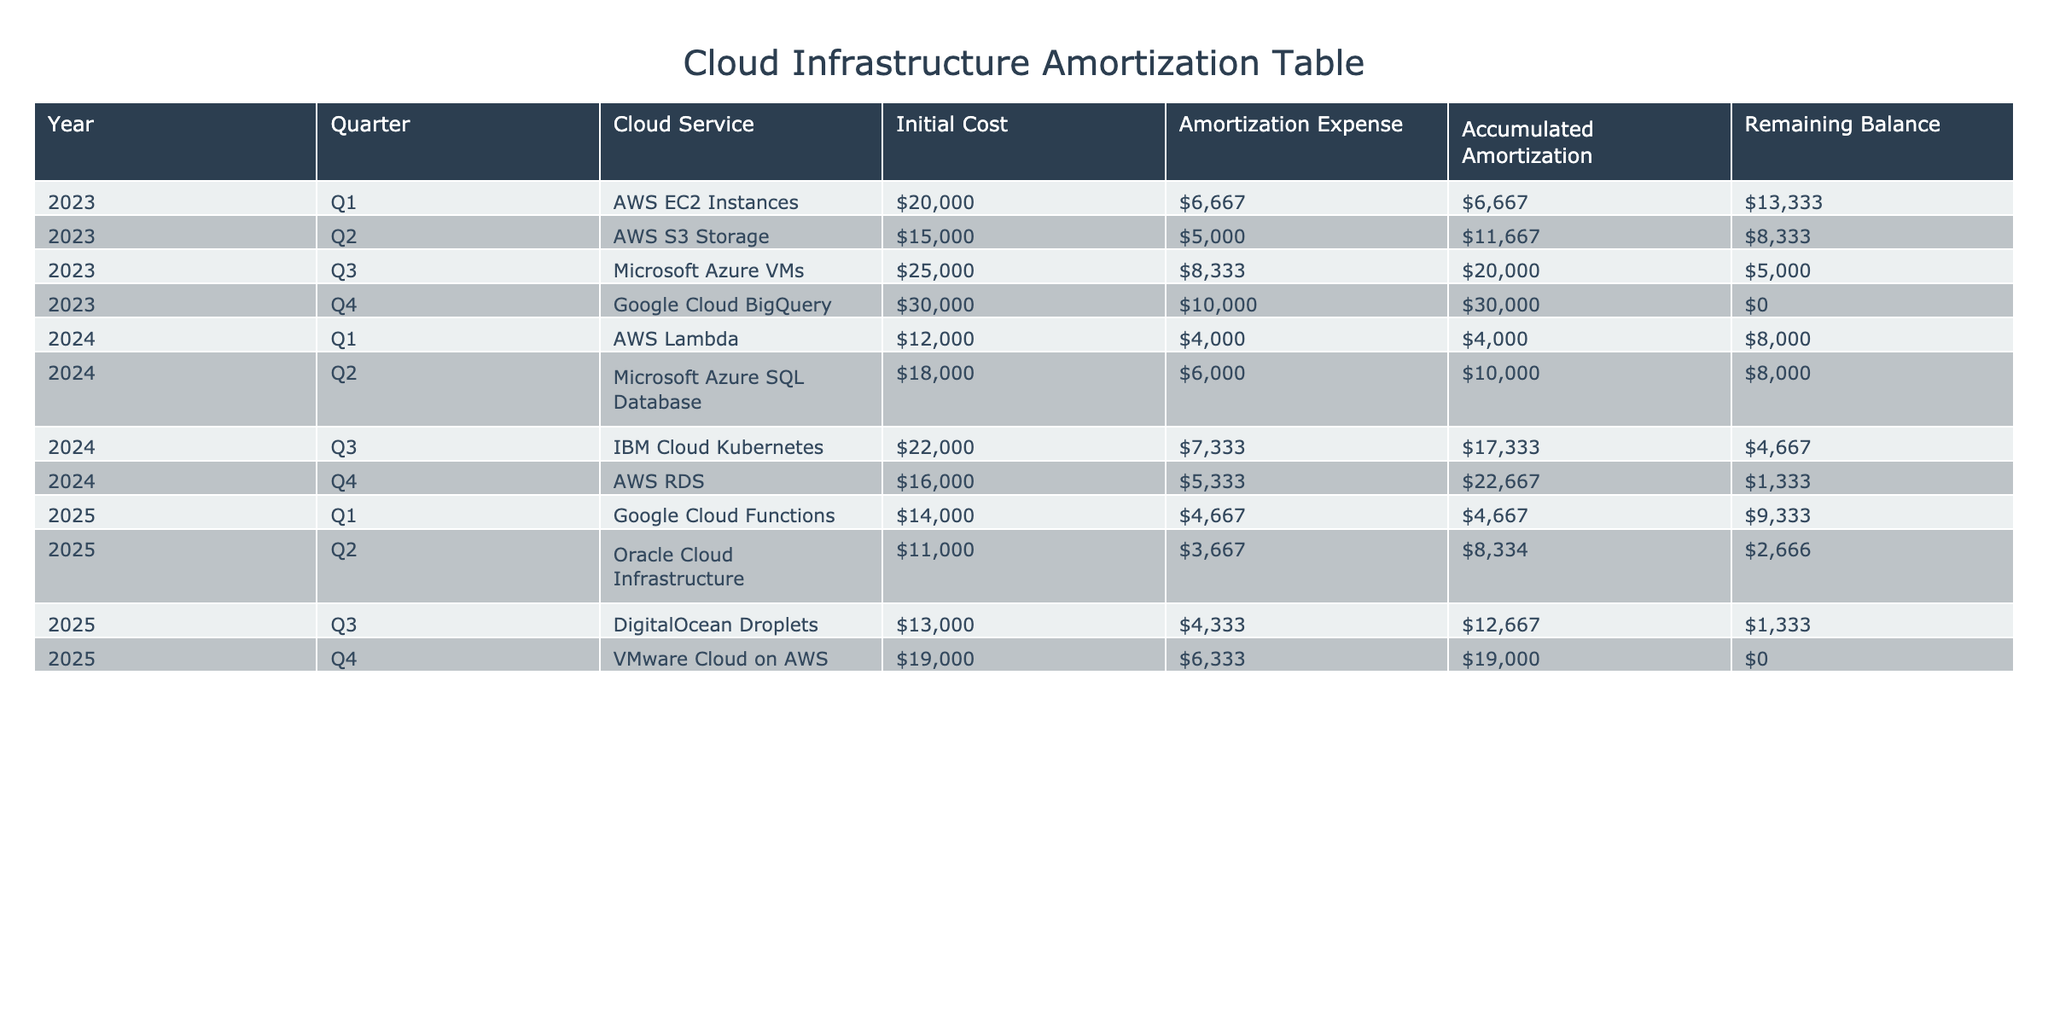What is the total Initial Cost for cloud services in 2023? The Initial Costs for cloud services in 2023 are: AWS EC2 Instances ($20,000), AWS S3 Storage ($15,000), Microsoft Azure VMs ($25,000), and Google Cloud BigQuery ($30,000). Adding these amounts: 20,000 + 15,000 + 25,000 + 30,000 = 90,000.
Answer: $90,000 How much was the Amortization Expense for Google Cloud BigQuery? From the table, the Amortization Expense for Google Cloud BigQuery in Q4 2023 is $10,000.
Answer: $10,000 Is the Remaining Balance for AWS RDS in Q4 2024 equal to $1,333? According to the table, the Remaining Balance for AWS RDS in Q4 2024 is $1,333, so the statement is true.
Answer: Yes What is the average Amortization Expense for the year 2024? The Amortization Expenses for 2024 are: $4,000 (Q1), $6,000 (Q2), $7,333 (Q3), and $5,333 (Q4). First, sum these amounts: 4,000 + 6,000 + 7,333 + 5,333 = 22,666. Then, divide by 4 (the number of entries): 22,666 / 4 = 5,666.5.
Answer: $5,666.50 Which cloud service had the highest Remaining Balance in Q2 2024? In Q2 2024, the Remaining Balances are: AWS Lambda ($8,000), Microsoft Azure SQL Database ($8,000), IBM Cloud Kubernetes ($4,667), and AWS RDS ($1,333). Highest value is $8,000 for both AWS Lambda and Microsoft Azure SQL Database.
Answer: AWS Lambda and Microsoft Azure SQL Database What is the total Accumulated Amortization at the end of 2025? At the end of 2025, the Accumulated Amortization values are: Q1 ($4,667), Q2 ($8,334), Q3 ($12,667), and Q4 ($19,000). Summing these gives: 4,667 + 8,334 + 12,667 + 19,000 = 44,668.
Answer: $44,668 Did AWS EC2 Instances have an Amortization Expense greater than $7,000? The Amortization Expense for AWS EC2 Instances in Q1 2023 is $6,667, which is less than $7,000, making this statement false.
Answer: No What is the Remaining Balance for DigitalOcean Droplets in Q3 2025? The Remaining Balance for DigitalOcean Droplets in Q3 2025 is $1,333 according to the table.
Answer: $1,333 What is the total Initial Cost across all cloud services listed? The Initial Costs in the table are: $20,000, $15,000, $25,000, $30,000, $12,000, $18,000, $22,000, $16,000, $14,000, $11,000, $13,000, and $19,000. When summed, this gives a total of $20,000 + 15,000 + 25,000 + 30,000 + 12,000 + 18,000 + 22,000 + 16,000 + 14,000 + 11,000 + 13,000 + 19,000 =  325,000.
Answer: $325,000 